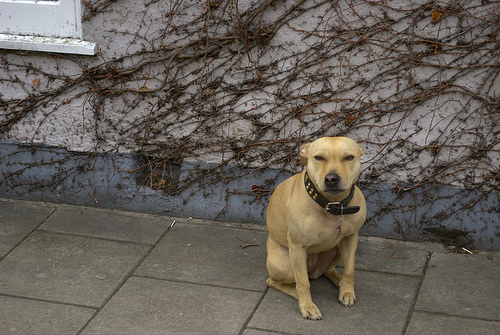What is the significance of the collar the dog is wearing? The collar is an important pet accessory, typically signifying ownership and responsibility. It may hold identification tags and is often used for securing a leash for walks. 